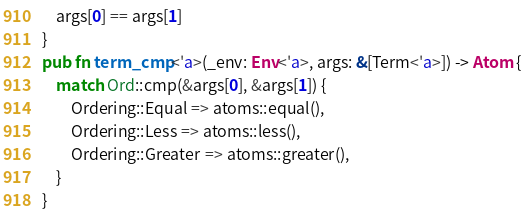<code> <loc_0><loc_0><loc_500><loc_500><_Rust_>    args[0] == args[1]
}
pub fn term_cmp<'a>(_env: Env<'a>, args: &[Term<'a>]) -> Atom {
    match Ord::cmp(&args[0], &args[1]) {
        Ordering::Equal => atoms::equal(),
        Ordering::Less => atoms::less(),
        Ordering::Greater => atoms::greater(),
    }
}
</code> 